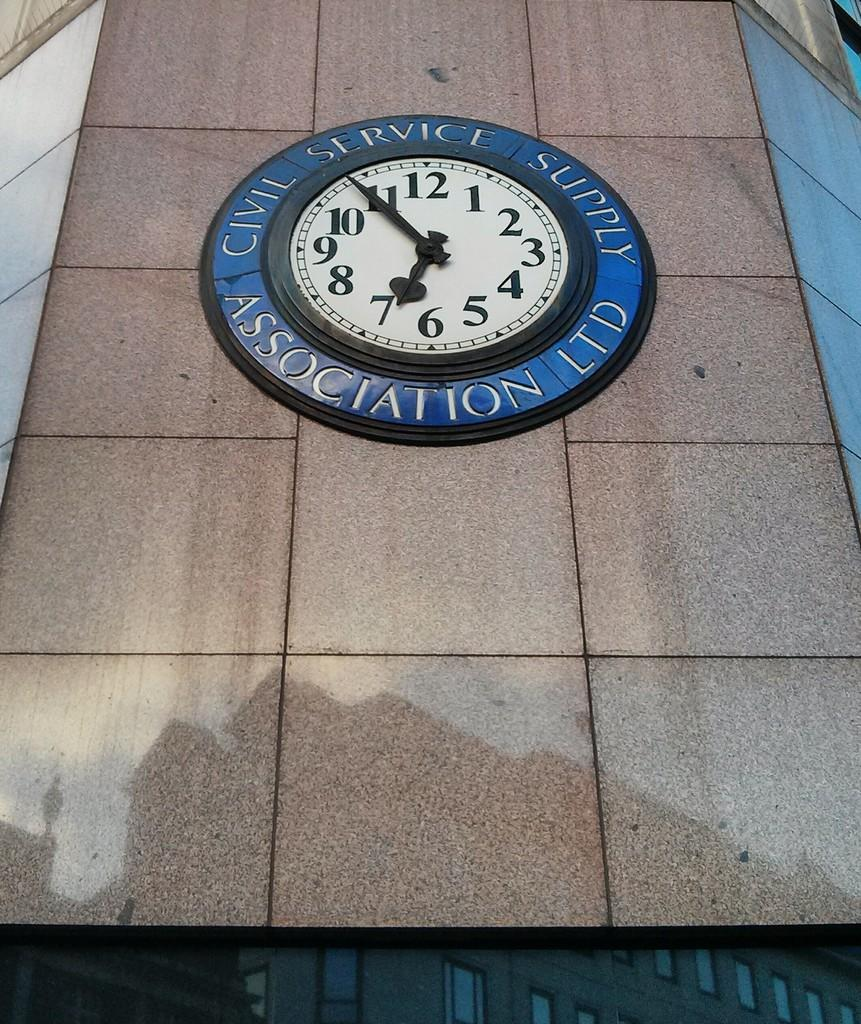<image>
Render a clear and concise summary of the photo. a large outdoor clock on a wall at 6:54 that says CIVIL SERVICE SUPPLY ASSOCIATION LTD 